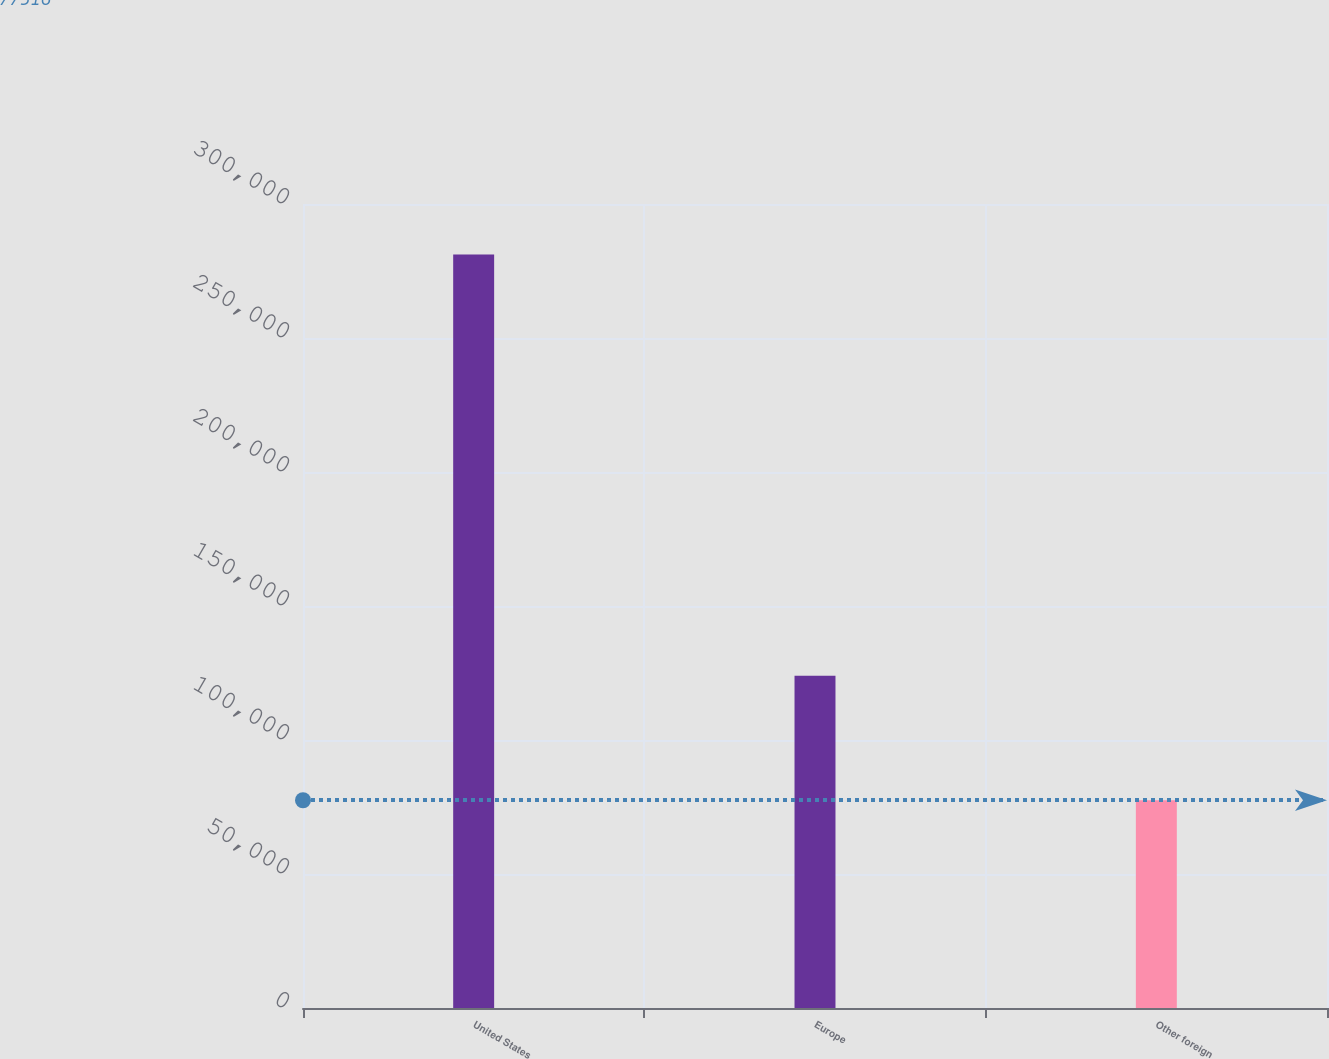Convert chart. <chart><loc_0><loc_0><loc_500><loc_500><bar_chart><fcel>United States<fcel>Europe<fcel>Other foreign<nl><fcel>281139<fcel>123996<fcel>77516<nl></chart> 